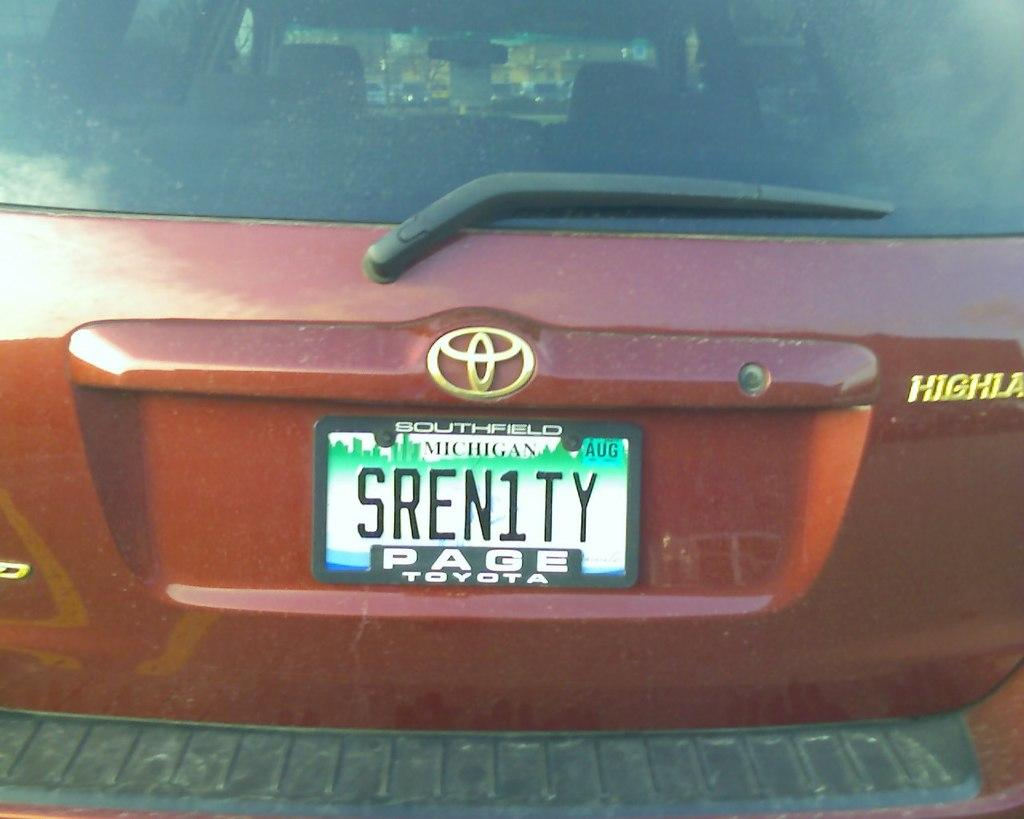What is the main subject of the image? The main subject of the image is a car. Where is the car located in the image? The car is on the ground in the image. What can be seen on the car that might help identify it? The car has a number plate in the image. What type of kiss can be seen between the car and the tree in the image? There is no kiss between the car and the tree in the image, as the image only features a car on the ground with a number plate. 